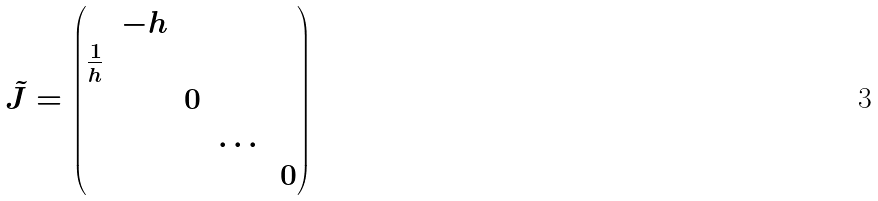Convert formula to latex. <formula><loc_0><loc_0><loc_500><loc_500>\tilde { J } = \begin{pmatrix} & - h & & & \\ \frac { 1 } { h } & & & & \\ & & 0 & & \\ & & & \dots & \\ & & & & 0 \\ \end{pmatrix}</formula> 